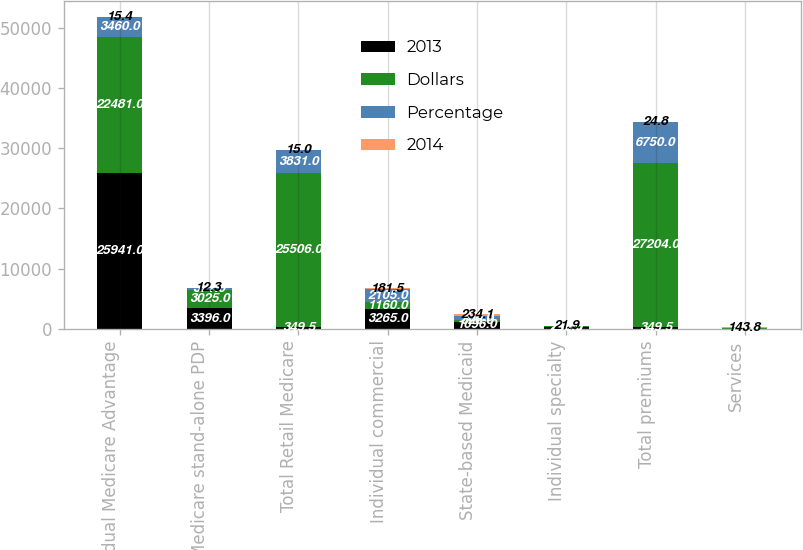Convert chart. <chart><loc_0><loc_0><loc_500><loc_500><stacked_bar_chart><ecel><fcel>Individual Medicare Advantage<fcel>Medicare stand-alone PDP<fcel>Total Retail Medicare<fcel>Individual commercial<fcel>State-based Medicaid<fcel>Individual specialty<fcel>Total premiums<fcel>Services<nl><fcel>2013<fcel>25941<fcel>3396<fcel>349.5<fcel>3265<fcel>1096<fcel>256<fcel>349.5<fcel>39<nl><fcel>Dollars<fcel>22481<fcel>3025<fcel>25506<fcel>1160<fcel>328<fcel>210<fcel>27204<fcel>16<nl><fcel>Percentage<fcel>3460<fcel>371<fcel>3831<fcel>2105<fcel>768<fcel>46<fcel>6750<fcel>23<nl><fcel>2014<fcel>15.4<fcel>12.3<fcel>15<fcel>181.5<fcel>234.1<fcel>21.9<fcel>24.8<fcel>143.8<nl></chart> 